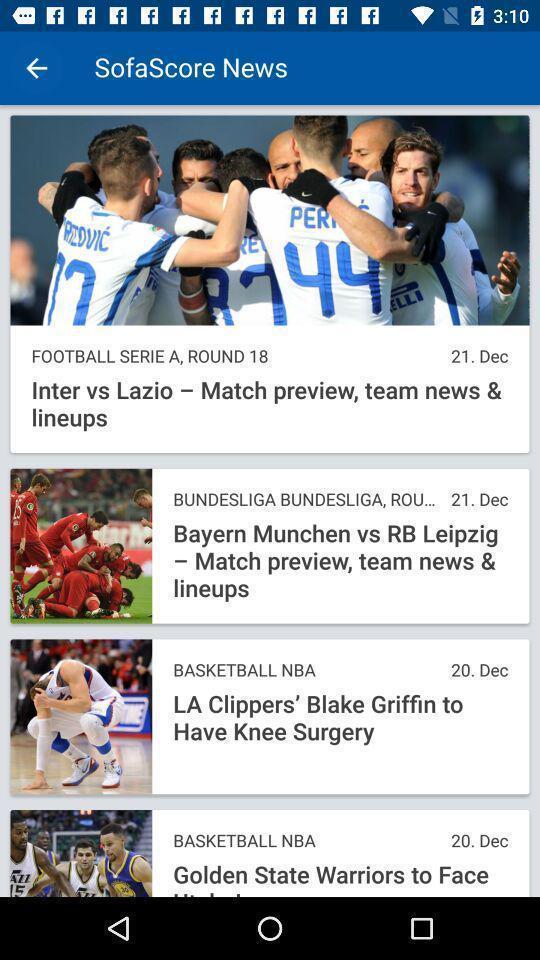Describe the key features of this screenshot. Screen displaying multiple sports articles information. 